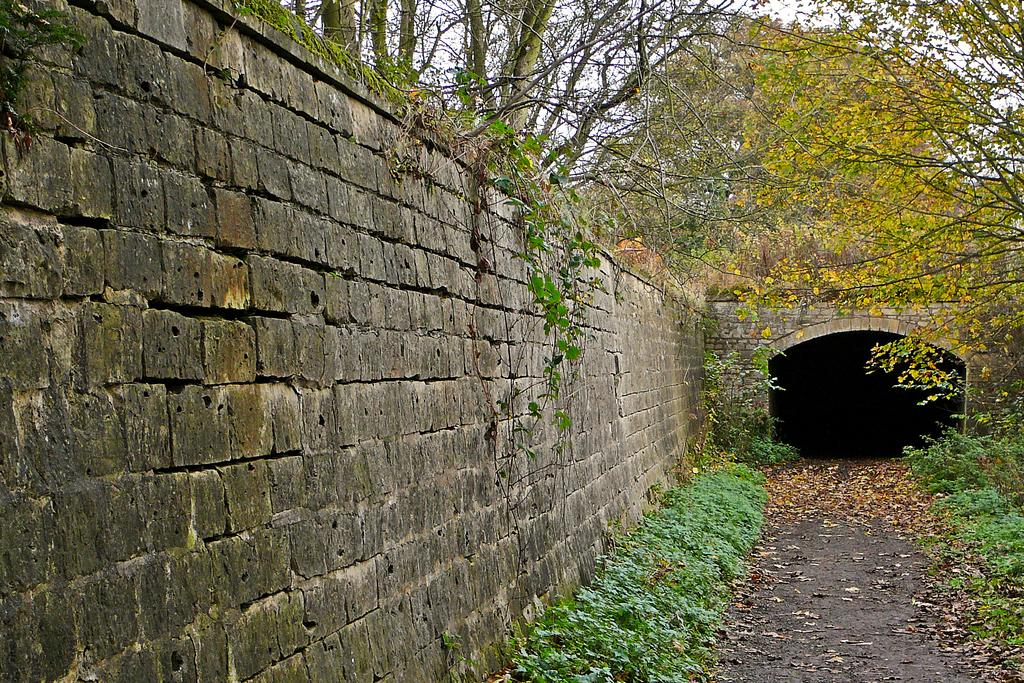What type of structure can be seen in the image? There is a wall in the image. Is there any specific architectural feature present in the image? Yes, there is an arch in the image. What type of vegetation is visible in the image? There are trees and plants in the image. What can be seen in the background of the image? The sky is visible in the background of the image. How many brothers are depicted in the image? There are no brothers present in the image; it features a wall, an arch, trees, plants, and the sky. What type of pie is being served in the image? There is no pie present in the image. 